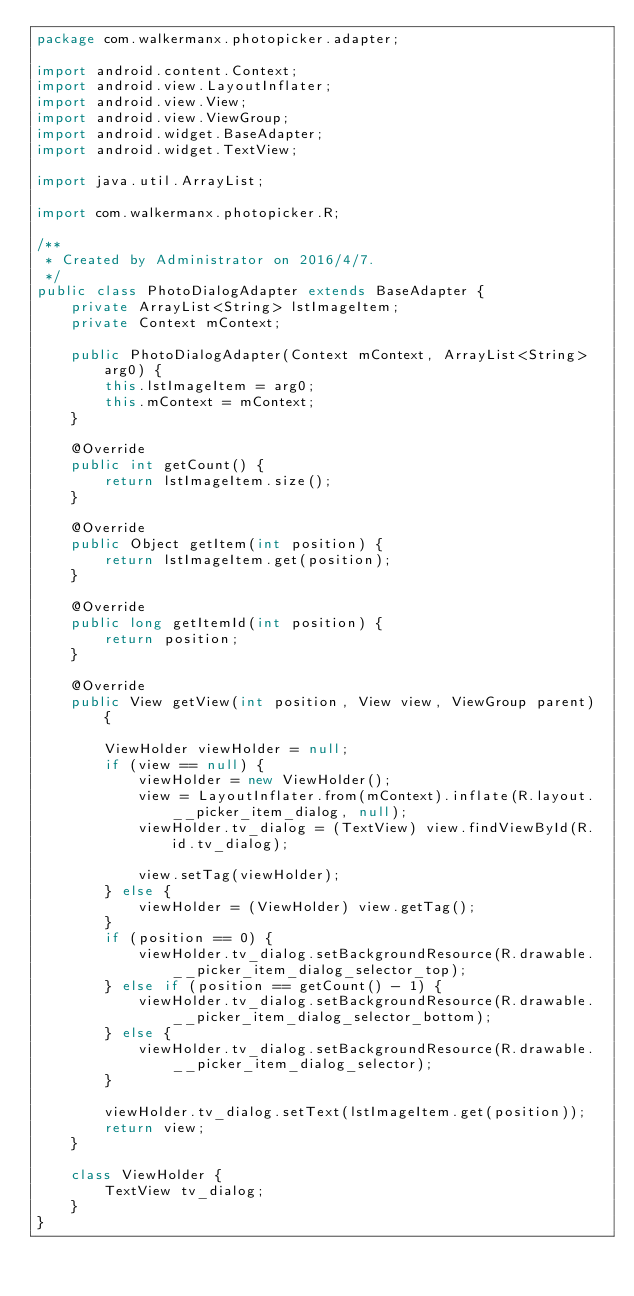<code> <loc_0><loc_0><loc_500><loc_500><_Java_>package com.walkermanx.photopicker.adapter;

import android.content.Context;
import android.view.LayoutInflater;
import android.view.View;
import android.view.ViewGroup;
import android.widget.BaseAdapter;
import android.widget.TextView;

import java.util.ArrayList;

import com.walkermanx.photopicker.R;

/**
 * Created by Administrator on 2016/4/7.
 */
public class PhotoDialogAdapter extends BaseAdapter {
    private ArrayList<String> lstImageItem;
    private Context mContext;

    public PhotoDialogAdapter(Context mContext, ArrayList<String> arg0) {
        this.lstImageItem = arg0;
        this.mContext = mContext;
    }

    @Override
    public int getCount() {
        return lstImageItem.size();
    }

    @Override
    public Object getItem(int position) {
        return lstImageItem.get(position);
    }

    @Override
    public long getItemId(int position) {
        return position;
    }

    @Override
    public View getView(int position, View view, ViewGroup parent) {

        ViewHolder viewHolder = null;
        if (view == null) {
            viewHolder = new ViewHolder();
            view = LayoutInflater.from(mContext).inflate(R.layout.__picker_item_dialog, null);
            viewHolder.tv_dialog = (TextView) view.findViewById(R.id.tv_dialog);

            view.setTag(viewHolder);
        } else {
            viewHolder = (ViewHolder) view.getTag();
        }
        if (position == 0) {
            viewHolder.tv_dialog.setBackgroundResource(R.drawable.__picker_item_dialog_selector_top);
        } else if (position == getCount() - 1) {
            viewHolder.tv_dialog.setBackgroundResource(R.drawable.__picker_item_dialog_selector_bottom);
        } else {
            viewHolder.tv_dialog.setBackgroundResource(R.drawable.__picker_item_dialog_selector);
        }

        viewHolder.tv_dialog.setText(lstImageItem.get(position));
        return view;
    }

    class ViewHolder {
        TextView tv_dialog;
    }
}</code> 